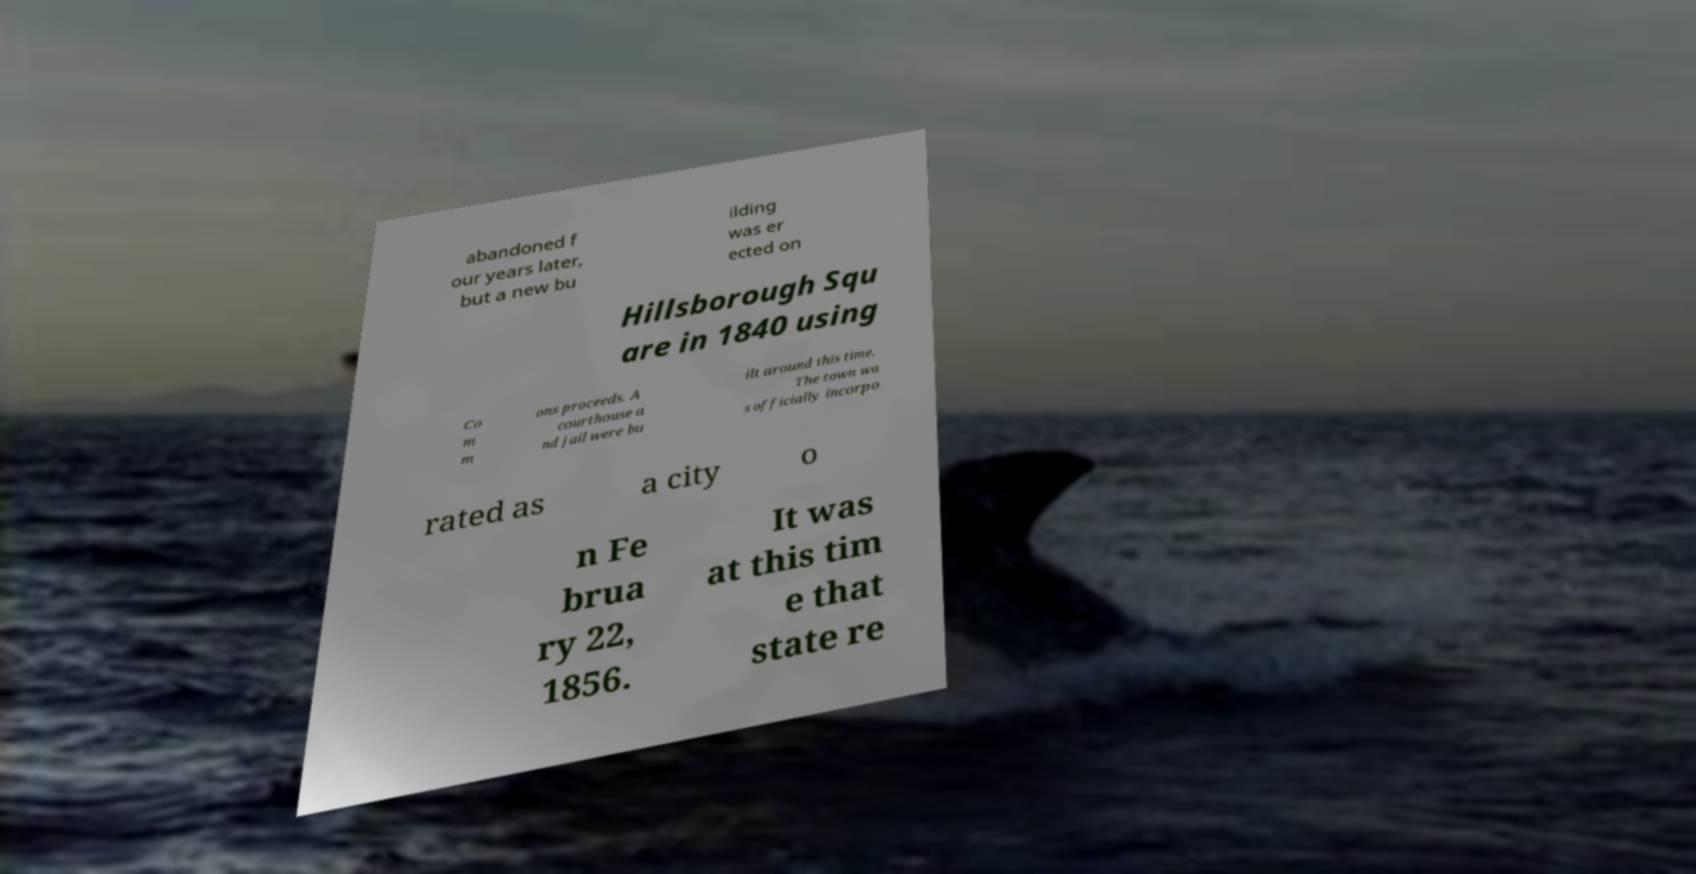Could you assist in decoding the text presented in this image and type it out clearly? abandoned f our years later, but a new bu ilding was er ected on Hillsborough Squ are in 1840 using Co m m ons proceeds. A courthouse a nd jail were bu ilt around this time. The town wa s officially incorpo rated as a city o n Fe brua ry 22, 1856. It was at this tim e that state re 